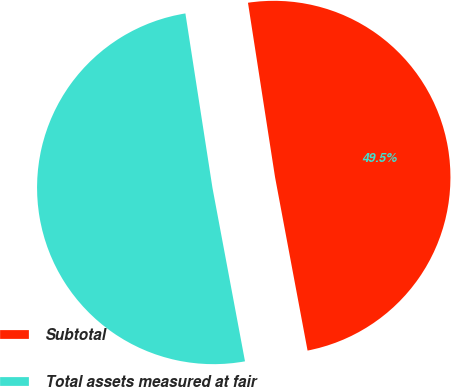<chart> <loc_0><loc_0><loc_500><loc_500><pie_chart><fcel>Subtotal<fcel>Total assets measured at fair<nl><fcel>49.5%<fcel>50.5%<nl></chart> 